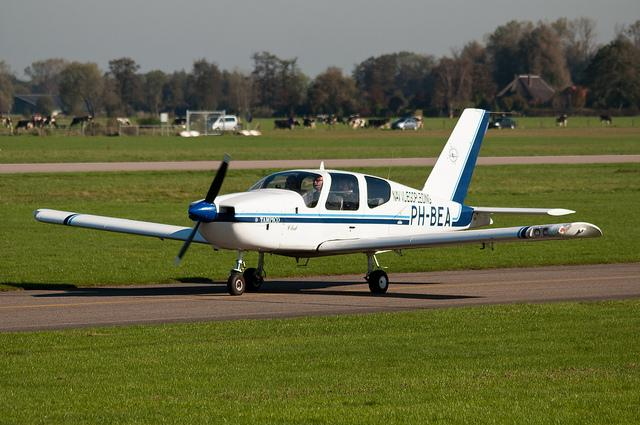What area is behind Plane runway?

Choices:
A) political building
B) cow field
C) munitions plant
D) mall cow field 